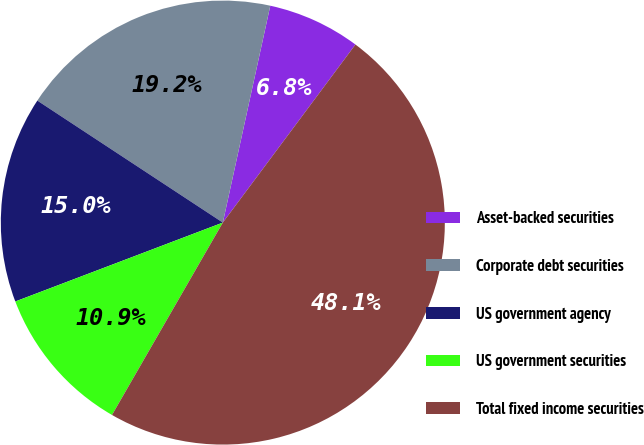Convert chart to OTSL. <chart><loc_0><loc_0><loc_500><loc_500><pie_chart><fcel>Asset-backed securities<fcel>Corporate debt securities<fcel>US government agency<fcel>US government securities<fcel>Total fixed income securities<nl><fcel>6.76%<fcel>19.17%<fcel>15.04%<fcel>10.9%<fcel>48.13%<nl></chart> 